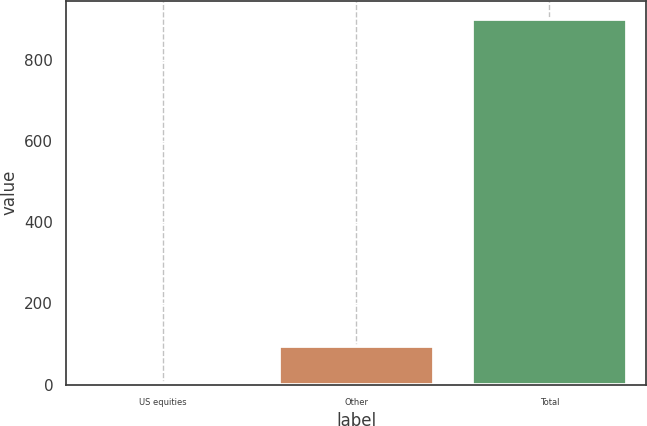Convert chart to OTSL. <chart><loc_0><loc_0><loc_500><loc_500><bar_chart><fcel>US equities<fcel>Other<fcel>Total<nl><fcel>5<fcel>94.5<fcel>900<nl></chart> 